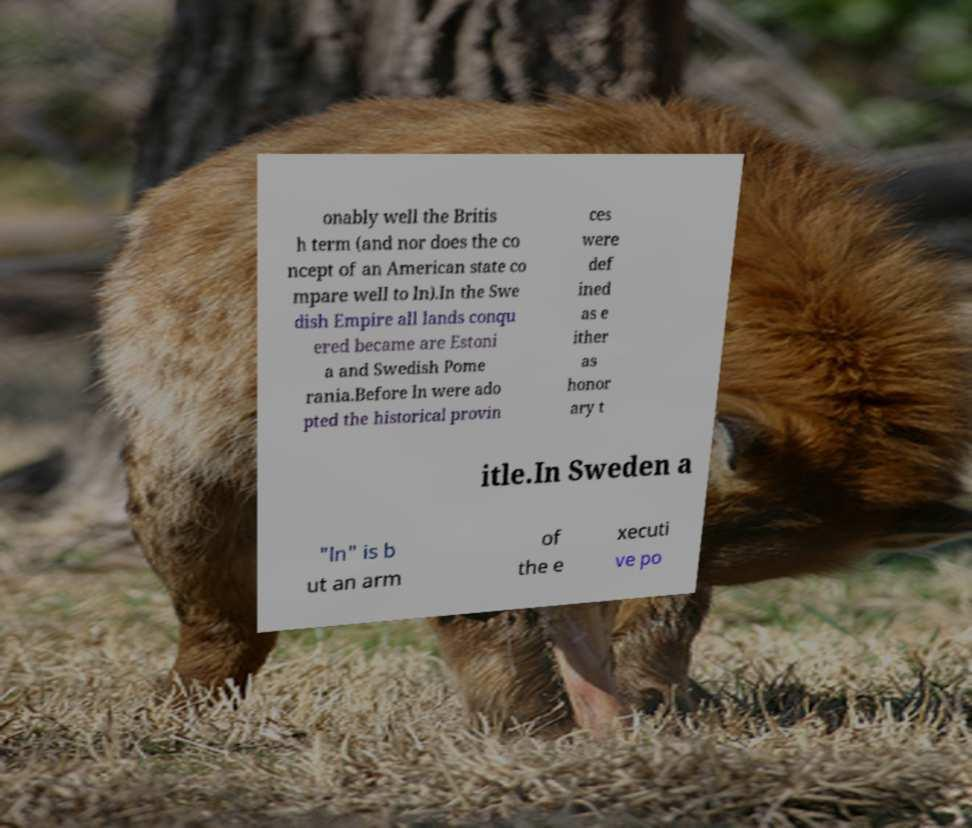Can you accurately transcribe the text from the provided image for me? onably well the Britis h term (and nor does the co ncept of an American state co mpare well to ln).In the Swe dish Empire all lands conqu ered became are Estoni a and Swedish Pome rania.Before ln were ado pted the historical provin ces were def ined as e ither as honor ary t itle.In Sweden a "ln" is b ut an arm of the e xecuti ve po 